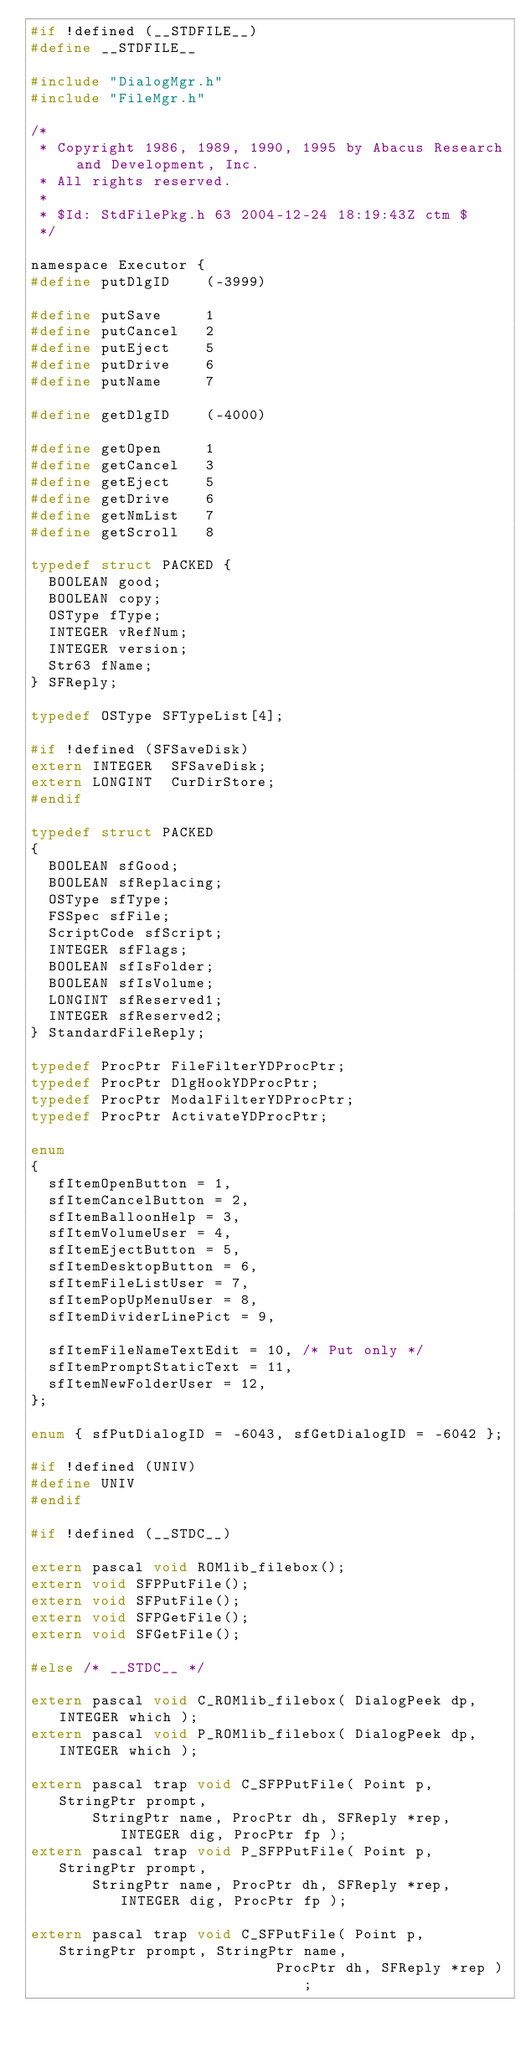Convert code to text. <code><loc_0><loc_0><loc_500><loc_500><_C_>#if !defined (__STDFILE__)
#define __STDFILE__

#include "DialogMgr.h"
#include "FileMgr.h"

/*
 * Copyright 1986, 1989, 1990, 1995 by Abacus Research and Development, Inc.
 * All rights reserved.
 *
 * $Id: StdFilePkg.h 63 2004-12-24 18:19:43Z ctm $
 */

namespace Executor {
#define putDlgID	(-3999)

#define putSave		1
#define putCancel	2
#define putEject	5
#define putDrive	6
#define putName		7

#define getDlgID	(-4000)

#define getOpen		1
#define getCancel	3
#define getEject	5
#define getDrive	6
#define getNmList	7
#define getScroll	8

typedef struct PACKED {
  BOOLEAN good;
  BOOLEAN copy;
  OSType fType;
  INTEGER vRefNum;
  INTEGER version;
  Str63 fName;
} SFReply;

typedef OSType SFTypeList[4];

#if !defined (SFSaveDisk)
extern INTEGER 	SFSaveDisk;
extern LONGINT 	CurDirStore;
#endif

typedef struct PACKED
{
  BOOLEAN sfGood;
  BOOLEAN sfReplacing;
  OSType sfType;
  FSSpec sfFile;
  ScriptCode sfScript;
  INTEGER sfFlags;
  BOOLEAN sfIsFolder;
  BOOLEAN sfIsVolume;
  LONGINT sfReserved1;
  INTEGER sfReserved2;
} StandardFileReply;

typedef ProcPtr FileFilterYDProcPtr;
typedef ProcPtr DlgHookYDProcPtr;
typedef ProcPtr ModalFilterYDProcPtr;
typedef ProcPtr ActivateYDProcPtr;

enum
{
  sfItemOpenButton = 1,
  sfItemCancelButton = 2,
  sfItemBalloonHelp = 3,
  sfItemVolumeUser = 4,
  sfItemEjectButton = 5,
  sfItemDesktopButton = 6,
  sfItemFileListUser = 7,
  sfItemPopUpMenuUser = 8,
  sfItemDividerLinePict = 9,
  
  sfItemFileNameTextEdit = 10, /* Put only */
  sfItemPromptStaticText = 11,
  sfItemNewFolderUser = 12,
};

enum { sfPutDialogID = -6043, sfGetDialogID = -6042 };

#if !defined (UNIV)
#define UNIV
#endif

#if !defined (__STDC__)

extern pascal void ROMlib_filebox();
extern void SFPPutFile();
extern void SFPutFile();
extern void SFPGetFile();
extern void SFGetFile();

#else /* __STDC__ */

extern pascal void C_ROMlib_filebox( DialogPeek dp, INTEGER which );
extern pascal void P_ROMlib_filebox( DialogPeek dp, INTEGER which );

extern pascal trap void C_SFPPutFile( Point p, StringPtr prompt,
	   StringPtr name, ProcPtr dh, SFReply *rep, INTEGER dig, ProcPtr fp );
extern pascal trap void P_SFPPutFile( Point p, StringPtr prompt,
	   StringPtr name, ProcPtr dh, SFReply *rep, INTEGER dig, ProcPtr fp );

extern pascal trap void C_SFPutFile( Point p, StringPtr prompt, StringPtr name,
						    ProcPtr dh, SFReply *rep );</code> 